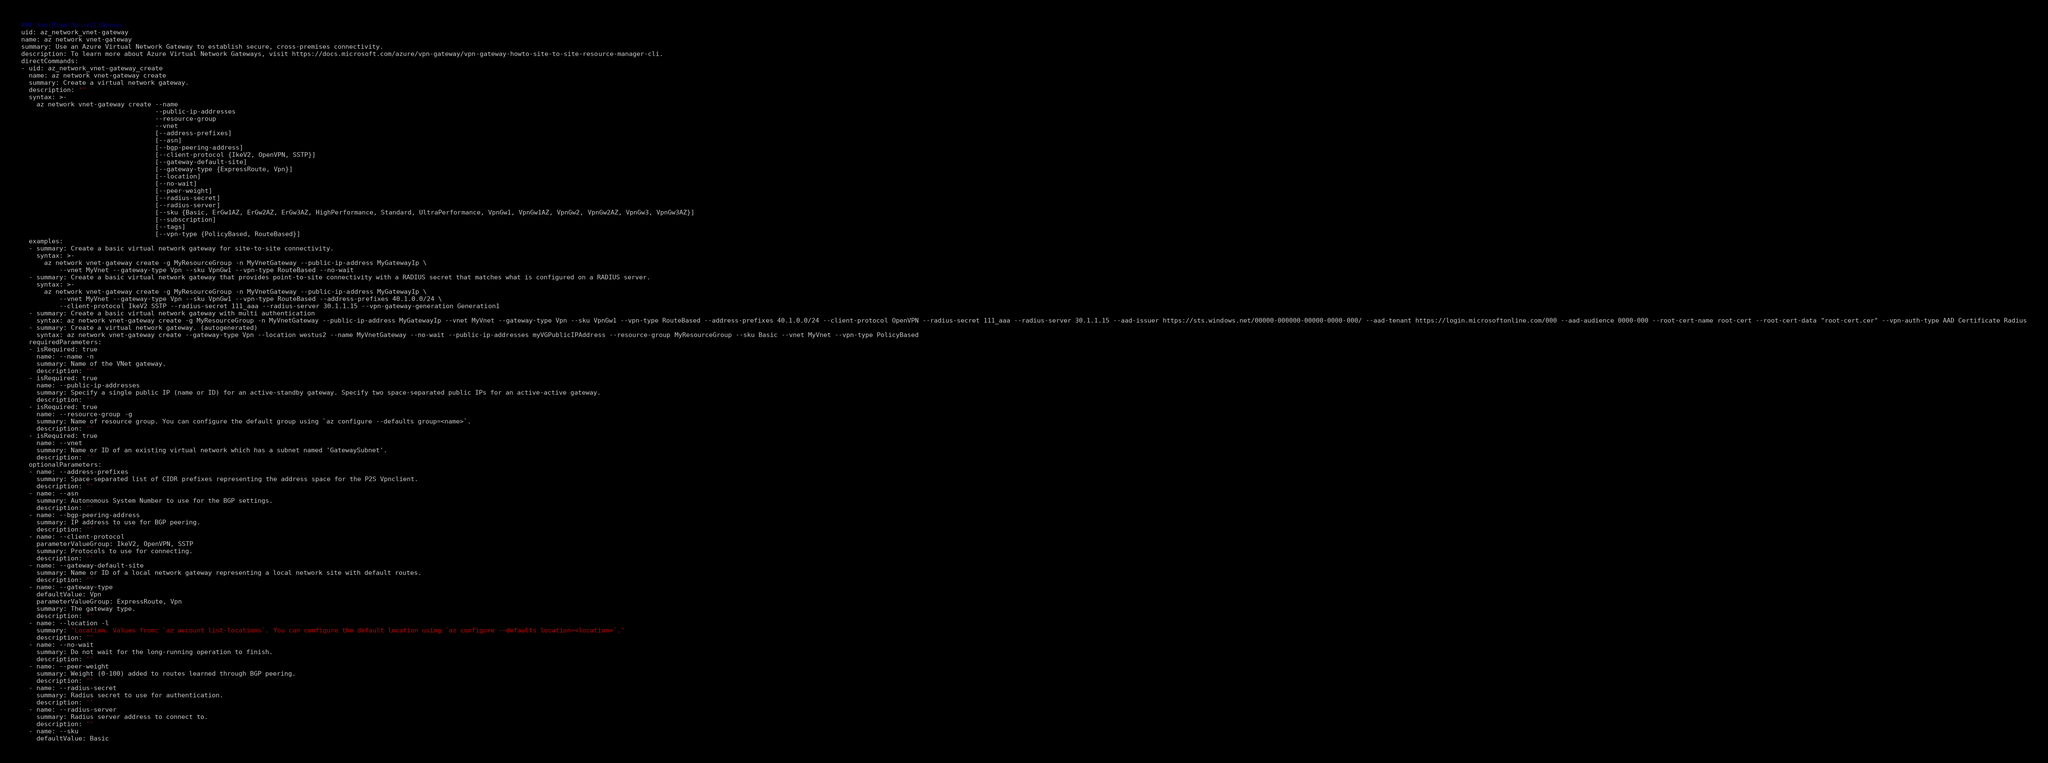<code> <loc_0><loc_0><loc_500><loc_500><_YAML_>### YamlMime:AzureCLIGroup
uid: az_network_vnet-gateway
name: az network vnet-gateway
summary: Use an Azure Virtual Network Gateway to establish secure, cross-premises connectivity.
description: To learn more about Azure Virtual Network Gateways, visit https://docs.microsoft.com/azure/vpn-gateway/vpn-gateway-howto-site-to-site-resource-manager-cli.
directCommands:
- uid: az_network_vnet-gateway_create
  name: az network vnet-gateway create
  summary: Create a virtual network gateway.
  description: ''
  syntax: >-
    az network vnet-gateway create --name
                                   --public-ip-addresses
                                   --resource-group
                                   --vnet
                                   [--address-prefixes]
                                   [--asn]
                                   [--bgp-peering-address]
                                   [--client-protocol {IkeV2, OpenVPN, SSTP}]
                                   [--gateway-default-site]
                                   [--gateway-type {ExpressRoute, Vpn}]
                                   [--location]
                                   [--no-wait]
                                   [--peer-weight]
                                   [--radius-secret]
                                   [--radius-server]
                                   [--sku {Basic, ErGw1AZ, ErGw2AZ, ErGw3AZ, HighPerformance, Standard, UltraPerformance, VpnGw1, VpnGw1AZ, VpnGw2, VpnGw2AZ, VpnGw3, VpnGw3AZ}]
                                   [--subscription]
                                   [--tags]
                                   [--vpn-type {PolicyBased, RouteBased}]
  examples:
  - summary: Create a basic virtual network gateway for site-to-site connectivity.
    syntax: >-
      az network vnet-gateway create -g MyResourceGroup -n MyVnetGateway --public-ip-address MyGatewayIp \
          --vnet MyVnet --gateway-type Vpn --sku VpnGw1 --vpn-type RouteBased --no-wait
  - summary: Create a basic virtual network gateway that provides point-to-site connectivity with a RADIUS secret that matches what is configured on a RADIUS server.
    syntax: >-
      az network vnet-gateway create -g MyResourceGroup -n MyVnetGateway --public-ip-address MyGatewayIp \
          --vnet MyVnet --gateway-type Vpn --sku VpnGw1 --vpn-type RouteBased --address-prefixes 40.1.0.0/24 \
          --client-protocol IkeV2 SSTP --radius-secret 111_aaa --radius-server 30.1.1.15 --vpn-gateway-generation Generation1
  - summary: Create a basic virtual network gateway with multi authentication
    syntax: az network vnet-gateway create -g MyResourceGroup -n MyVnetGateway --public-ip-address MyGatewayIp --vnet MyVnet --gateway-type Vpn --sku VpnGw1 --vpn-type RouteBased --address-prefixes 40.1.0.0/24 --client-protocol OpenVPN --radius-secret 111_aaa --radius-server 30.1.1.15 --aad-issuer https://sts.windows.net/00000-000000-00000-0000-000/ --aad-tenant https://login.microsoftonline.com/000 --aad-audience 0000-000 --root-cert-name root-cert --root-cert-data "root-cert.cer" --vpn-auth-type AAD Certificate Radius
  - summary: Create a virtual network gateway. (autogenerated)
    syntax: az network vnet-gateway create --gateway-type Vpn --location westus2 --name MyVnetGateway --no-wait --public-ip-addresses myVGPublicIPAddress --resource-group MyResourceGroup --sku Basic --vnet MyVnet --vpn-type PolicyBased
  requiredParameters:
  - isRequired: true
    name: --name -n
    summary: Name of the VNet gateway.
    description: ''
  - isRequired: true
    name: --public-ip-addresses
    summary: Specify a single public IP (name or ID) for an active-standby gateway. Specify two space-separated public IPs for an active-active gateway.
    description: ''
  - isRequired: true
    name: --resource-group -g
    summary: Name of resource group. You can configure the default group using `az configure --defaults group=<name>`.
    description: ''
  - isRequired: true
    name: --vnet
    summary: Name or ID of an existing virtual network which has a subnet named 'GatewaySubnet'.
    description: ''
  optionalParameters:
  - name: --address-prefixes
    summary: Space-separated list of CIDR prefixes representing the address space for the P2S Vpnclient.
    description: ''
  - name: --asn
    summary: Autonomous System Number to use for the BGP settings.
    description: ''
  - name: --bgp-peering-address
    summary: IP address to use for BGP peering.
    description: ''
  - name: --client-protocol
    parameterValueGroup: IkeV2, OpenVPN, SSTP
    summary: Protocols to use for connecting.
    description: ''
  - name: --gateway-default-site
    summary: Name or ID of a local network gateway representing a local network site with default routes.
    description: ''
  - name: --gateway-type
    defaultValue: Vpn
    parameterValueGroup: ExpressRoute, Vpn
    summary: The gateway type.
    description: ''
  - name: --location -l
    summary: 'Location. Values from: `az account list-locations`. You can configure the default location using `az configure --defaults location=<location>`.'
    description: ''
  - name: --no-wait
    summary: Do not wait for the long-running operation to finish.
    description: ''
  - name: --peer-weight
    summary: Weight (0-100) added to routes learned through BGP peering.
    description: ''
  - name: --radius-secret
    summary: Radius secret to use for authentication.
    description: ''
  - name: --radius-server
    summary: Radius server address to connect to.
    description: ''
  - name: --sku
    defaultValue: Basic</code> 